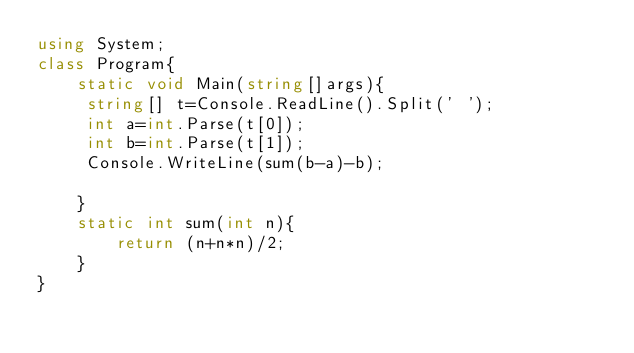Convert code to text. <code><loc_0><loc_0><loc_500><loc_500><_C#_>using System;
class Program{
    static void Main(string[]args){
     string[] t=Console.ReadLine().Split(' ');
     int a=int.Parse(t[0]);
     int b=int.Parse(t[1]);
     Console.WriteLine(sum(b-a)-b);

    }
    static int sum(int n){
        return (n+n*n)/2;
    }
}</code> 